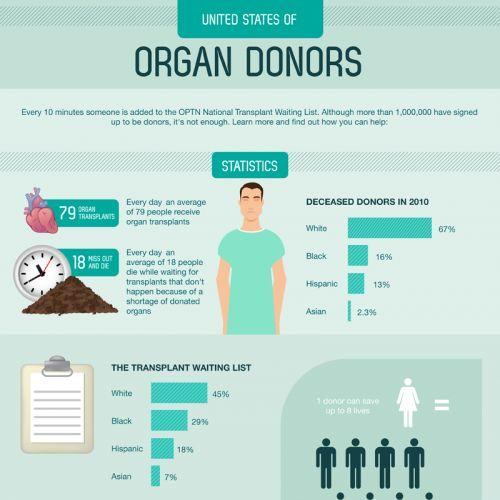Point out several critical features in this image. The percentage of deceased donors in 2010 was lower for Hispanics than for Whites and Blacks. There is a 64.7% difference between the percentage of deceased donors from the White race and the percentage of deceased donors from the Asian race. In 2010, the total percentage of donors who were deceased was 98.3% in the categories of White, Black, Hispanic, and Asian. The total percentage of people on the transplant waiting list is 99%. The Asian, Black, and Hispanic communities have higher percentages of individuals on organ transplant waiting lists. However, the Black community has the highest percentage of individuals on the waiting list. 